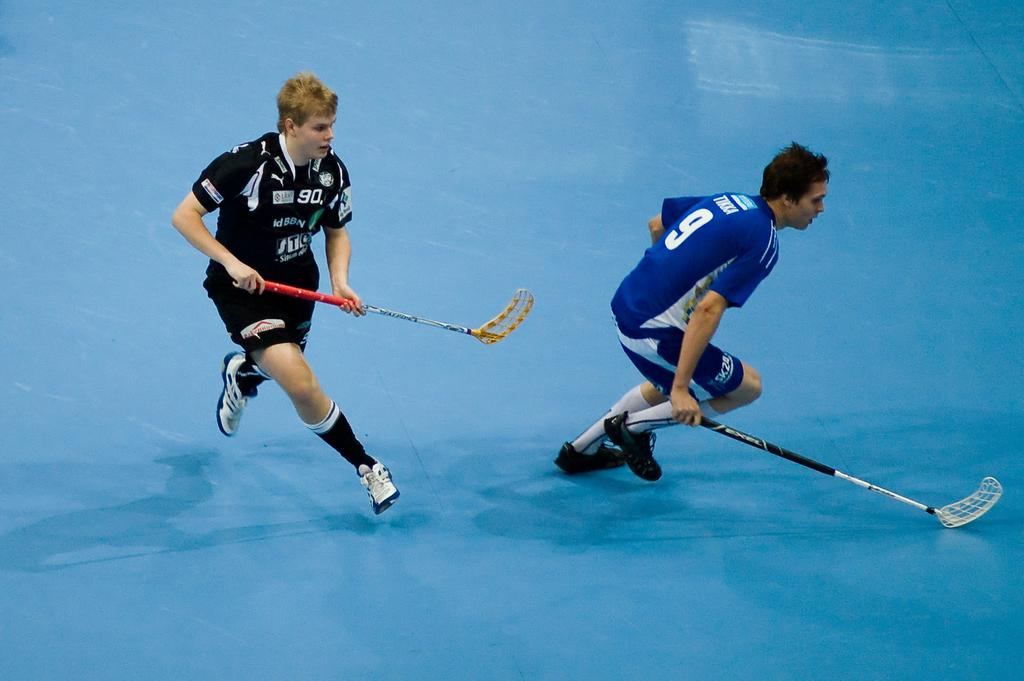How many people are in the image? There are two men in the image. What are the men wearing? Both men are wearing t-shirts and shorts. What objects are the men holding in their hands? The men are holding bats in their hands. What activity are the men engaged in? The men are playing a game on the floor. What type of stocking is the man wearing on his head in the image? There is no man wearing a stocking on his head in the image. Can you read the caption of the game the men are playing in the image? There is no caption present in the image. 